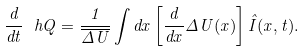<formula> <loc_0><loc_0><loc_500><loc_500>\frac { d } { d t } \ h Q = \frac { 1 } { \overline { \Delta U } } \int d x \left [ \frac { d } { d x } \Delta U ( x ) \right ] \hat { I } ( x , t ) .</formula> 